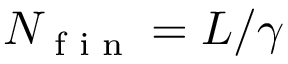Convert formula to latex. <formula><loc_0><loc_0><loc_500><loc_500>N _ { f i n } = L / \gamma</formula> 